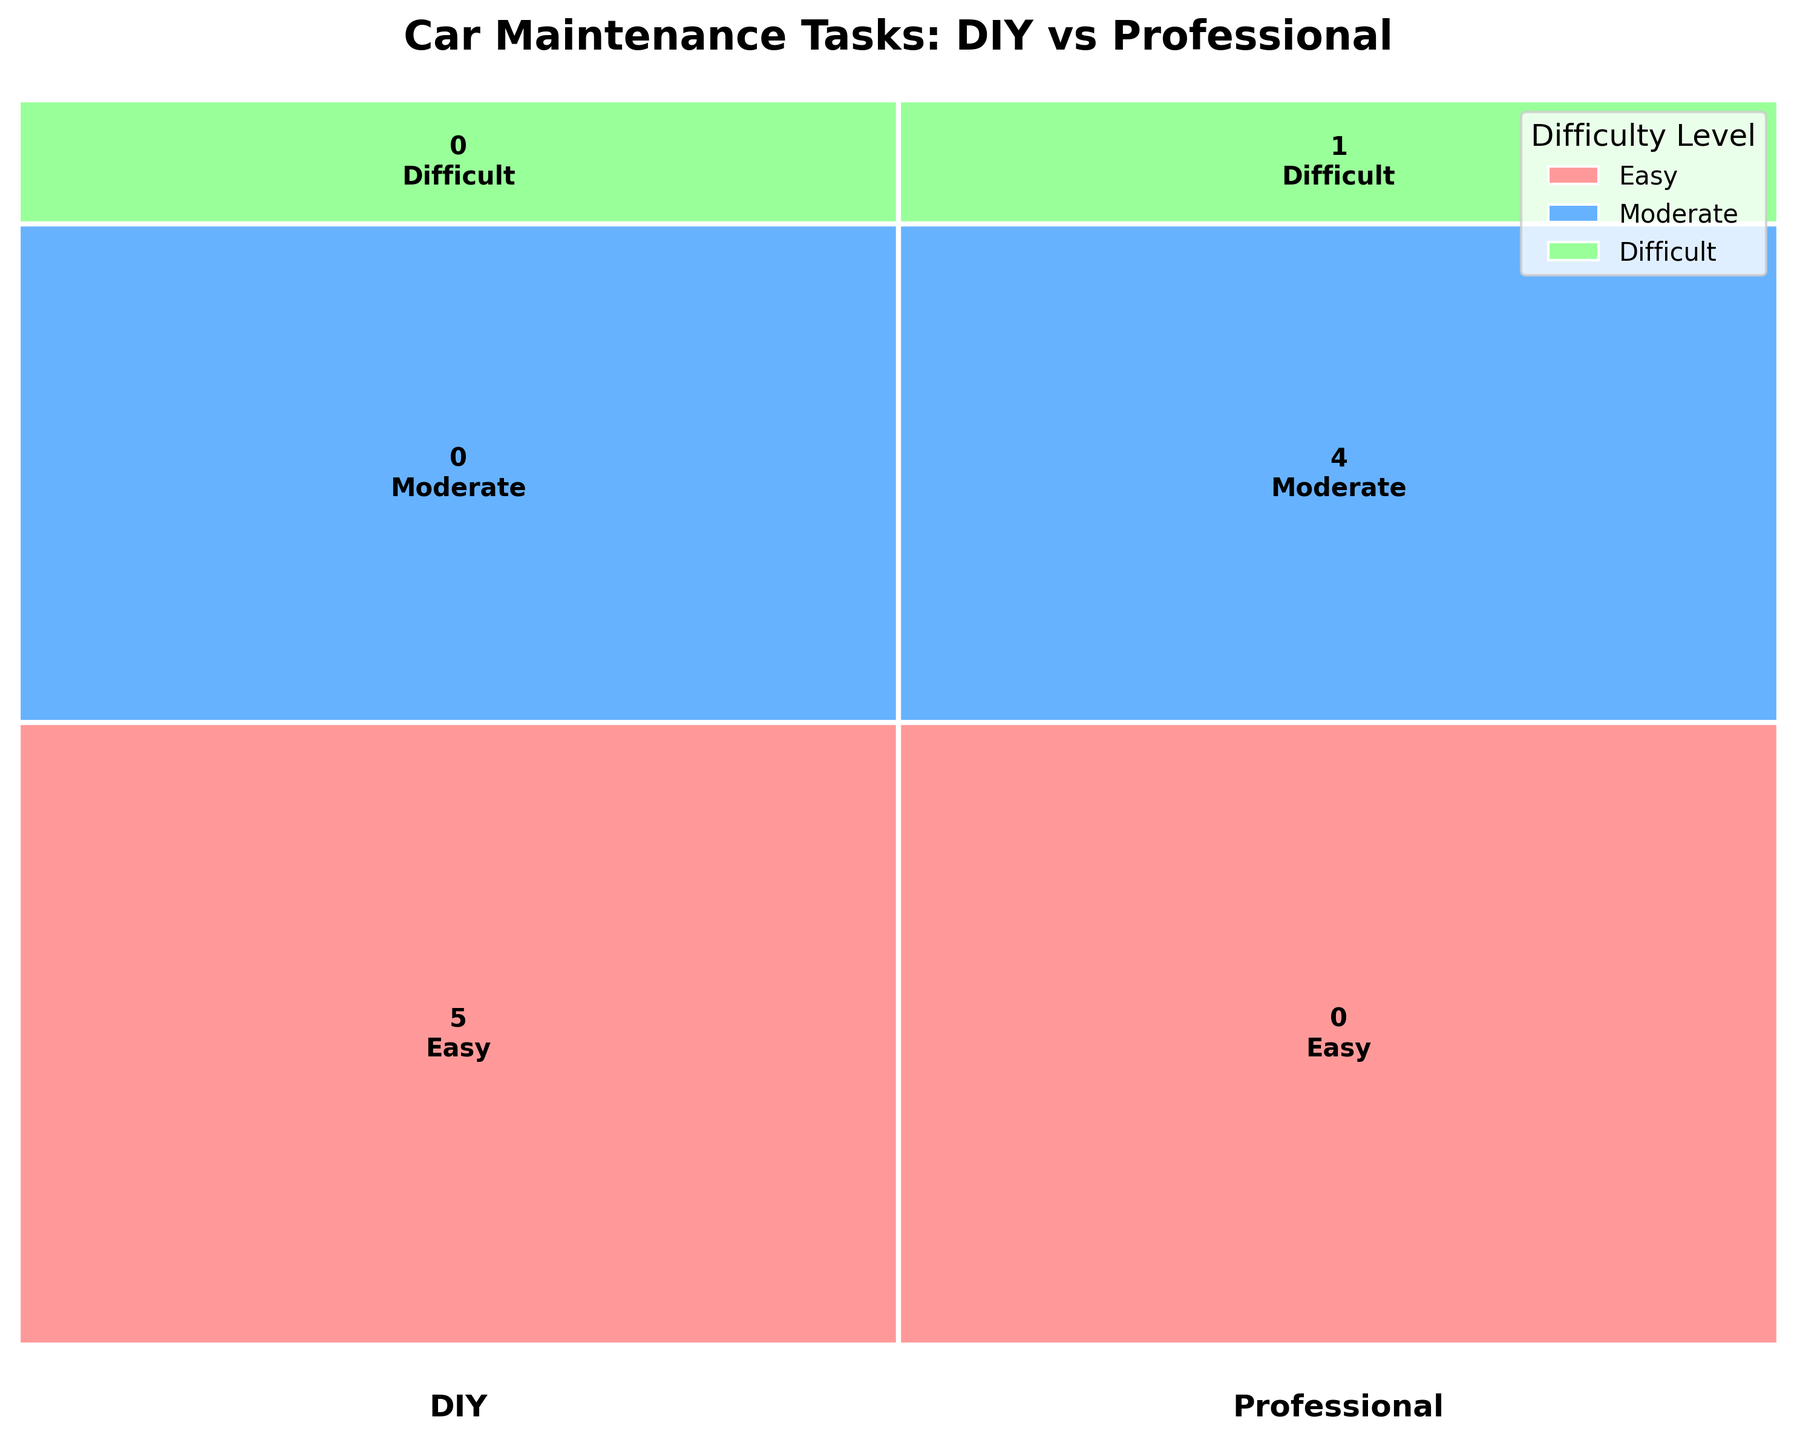How many tasks are recommended for DIY? The mosaic plot shows the number of tasks classified under "DIY". To find this number, count the text labels under the "DIY" column.
Answer: 5 How does the difficulty level of tasks recommended for professionals compare to DIY? Review the sections labeled "Professional" and note the levels of difficulty mentioned (i.e., Easy, Moderate, Difficult). Do the same for "DIY" and compare.
Answer: Tasks for professionals are typically more difficult or require moderate difficulty compared to DIY tasks Which difficulty level is associated with the highest number of tasks overall in the plot? Sum the tasks across both "DIY" and "Professional" for each difficulty level (Easy, Moderate, and Difficult) and identify the highest total.
Answer: Easy Which type of service (DIY or Professional) takes the most time on average? Look at the time requirements listed within each recommendation category, calculate the average time for both DIY and Professional, and compare.
Answer: DIY Are there any difficult tasks recommended for DIY? Look for any tasks classified as "Difficult" and verify if they fall under the "DIY" category.
Answer: No What percentage of easy tasks are recommended as DIY? Count the easy tasks under DIY and divide by the total number of easy tasks, then multiply by 100 to get the percentage.
Answer: 80% Do any moderate tasks have a time requirement of less than 1 hour? Check the moderate tasks listed and note any with a time requirement of less than 1 hour.
Answer: No Which category (DIY or Professional) has more tasks that take over 2 hours? Compare the number of tasks under both categories that specify a time requirement greater than 2 hours.
Answer: Professional Which service recommendation has the most tasks that can be completed in under 1 hour? Count the tasks with a time requirement of under 1 hour for both DIY and Professional categories and compare.
Answer: DIY Are timing belt replacements recommended as DIY or Professional tasks? Look for the task named "Timing Belt Replacement" and note the corresponding recommendation given.
Answer: Professional 